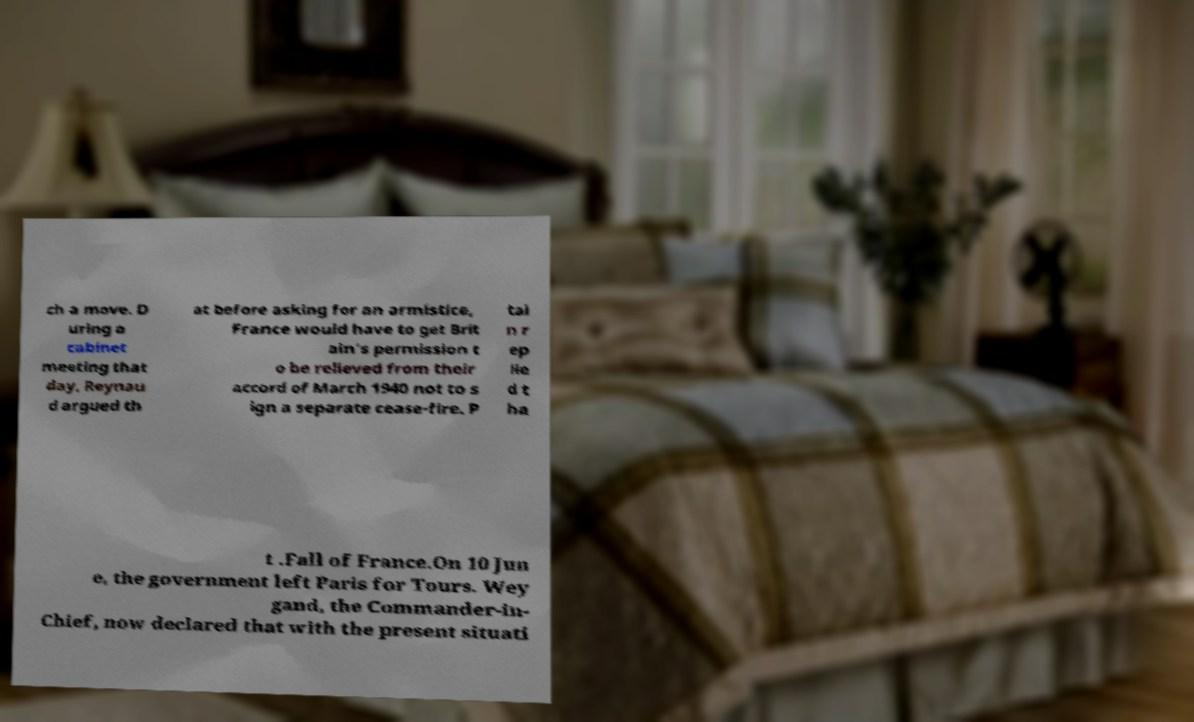Please identify and transcribe the text found in this image. ch a move. D uring a cabinet meeting that day, Reynau d argued th at before asking for an armistice, France would have to get Brit ain's permission t o be relieved from their accord of March 1940 not to s ign a separate cease-fire. P tai n r ep lie d t ha t .Fall of France.On 10 Jun e, the government left Paris for Tours. Wey gand, the Commander-in- Chief, now declared that with the present situati 